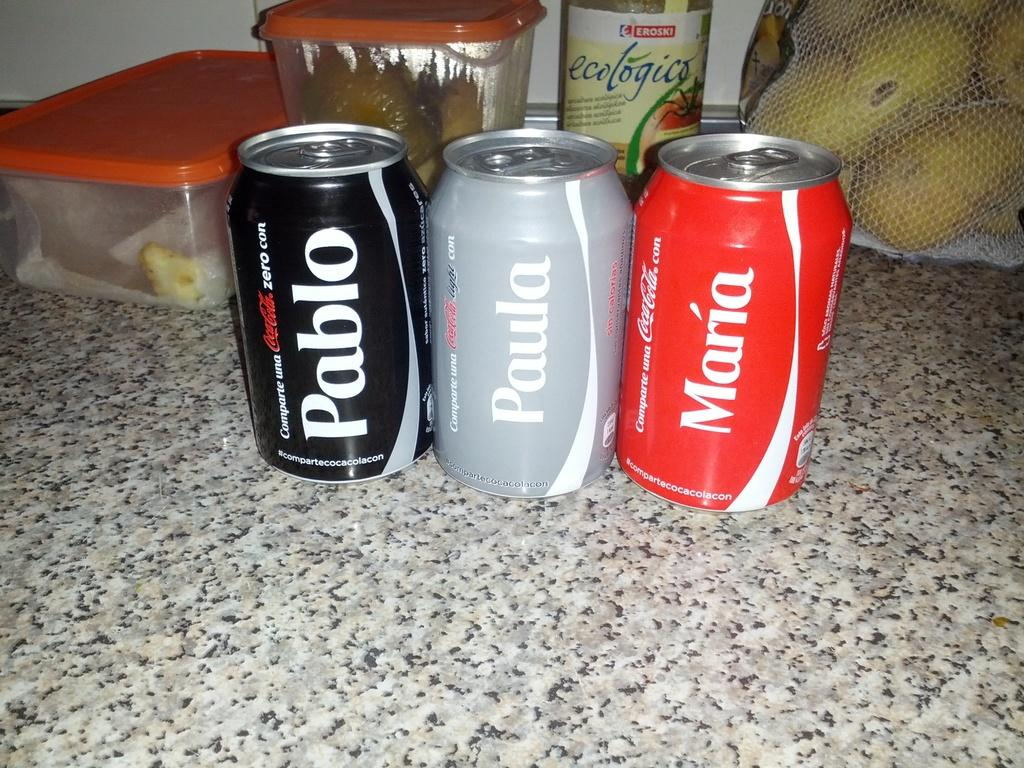<image>
Describe the image concisely. Pablo, Paula and Maria are the names on these three cans of coke. 